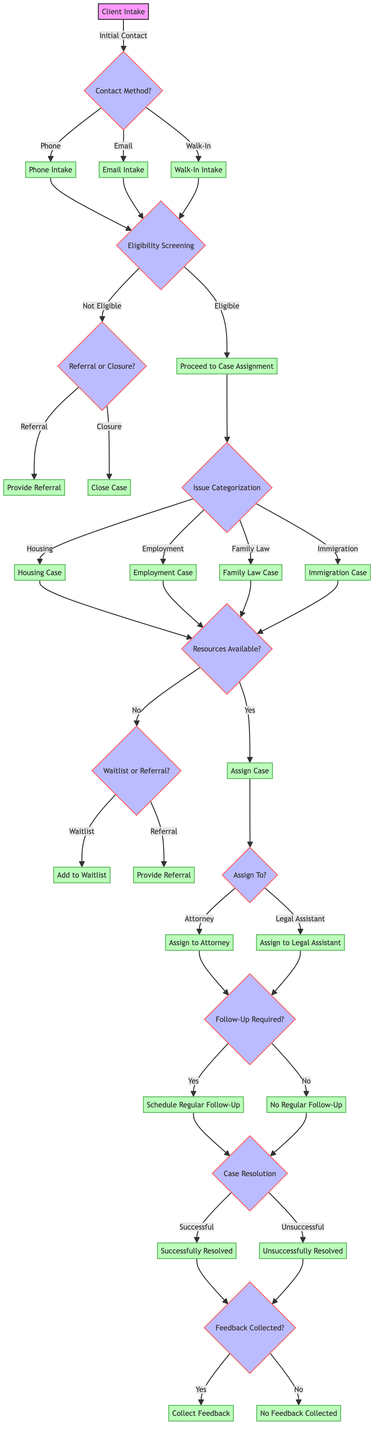What is the first step in the Client Intake process? The diagram starts with "Initial Contact" as the first step in the Client Intake process.
Answer: Initial Contact How many outcomes are there after the Eligibility Screening step? The Eligibility Screening leads to three outcomes: Eligible, Not Eligible - Referral, and Not Eligible - Closure, resulting in a total of three outcomes.
Answer: Three What types of issues can trigger Case Assignment? The diagram categorizes issues into four types: Housing, Employment, Family Law, and Immigration; thus, these four categories can trigger Case Assignment.
Answer: Four If the resources are not available, what two options do we have? If resources are not available, there are two paths: "Waitlist" and "Referral," leading to these two alternative options.
Answer: Waitlist, Referral What happens if a case is successfully resolved? If a case is successfully resolved, it leads to the "Successfully Resolved" outcome, indicating a positive resolution for the client.
Answer: Successfully Resolved What is the last step in Case Closure? The last step in Case Closure is "Feedback Collection," where it is determined if client feedback was collected.
Answer: Feedback Collection How does a case move to the Follow-Up step? A case moves to the Follow-Up step after the assignment to an attorney or legal assistant through the "Assign Case" step; it checks if regular follow-up is required.
Answer: Assign Case What decision is made based on the client's eligibility status? The client's eligibility status determines whether to proceed to Case Assignment, provide a referral, or close the case based on the Eligibility Screening outcome.
Answer: Referral, Closure How many types of attorneys or legal assistants can be assigned to a case? The diagram indicates two types of assignments: an attorney and a legal assistant, which means there are two options for case assignment.
Answer: Two 